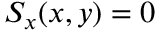Convert formula to latex. <formula><loc_0><loc_0><loc_500><loc_500>S _ { x } ( x , y ) = 0</formula> 